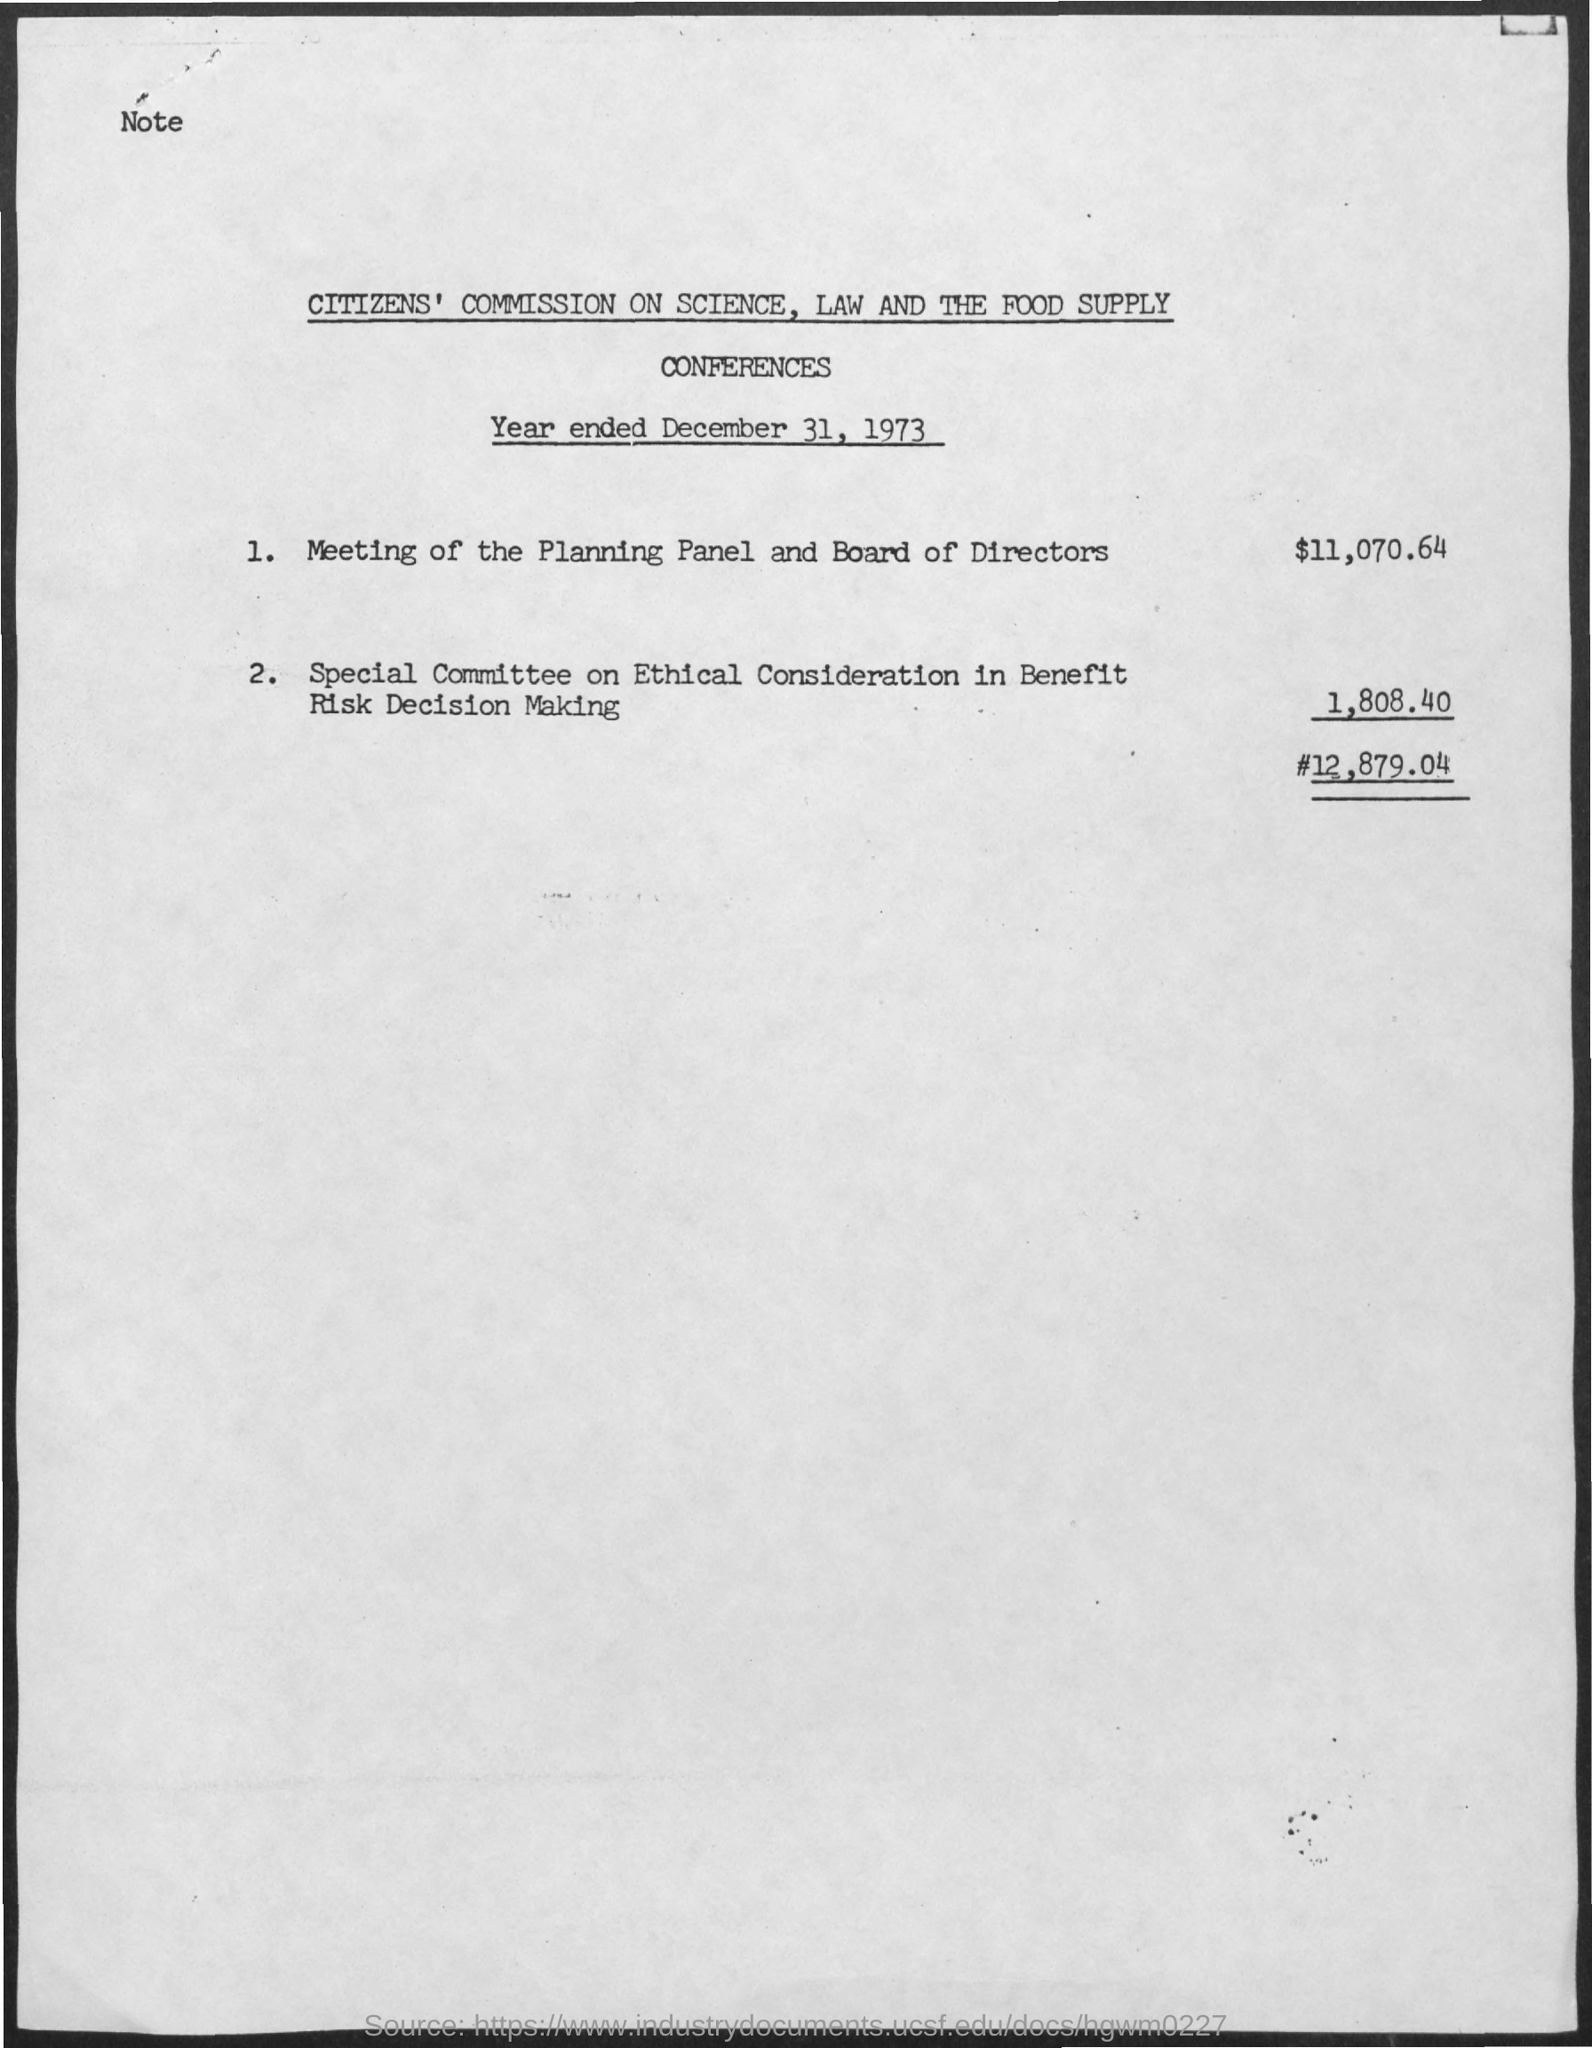Identify some key points in this picture. The date on the document is December 31, 1973. The special committee on ethical considerations in benefit-risk decision making requires an amount of $1,808.40. The amount for the meeting of the planning panel and board of directors is $11,070.64. 